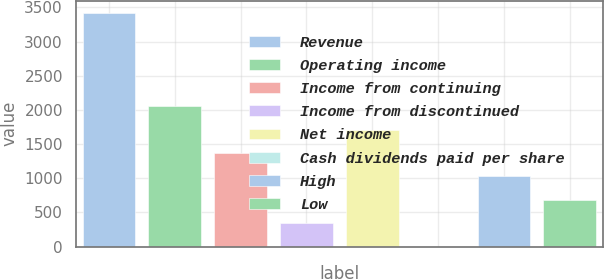<chart> <loc_0><loc_0><loc_500><loc_500><bar_chart><fcel>Revenue<fcel>Operating income<fcel>Income from continuing<fcel>Income from discontinued<fcel>Net income<fcel>Cash dividends paid per share<fcel>High<fcel>Low<nl><fcel>3422<fcel>2053.21<fcel>1368.83<fcel>342.26<fcel>1711.02<fcel>0.07<fcel>1026.64<fcel>684.45<nl></chart> 